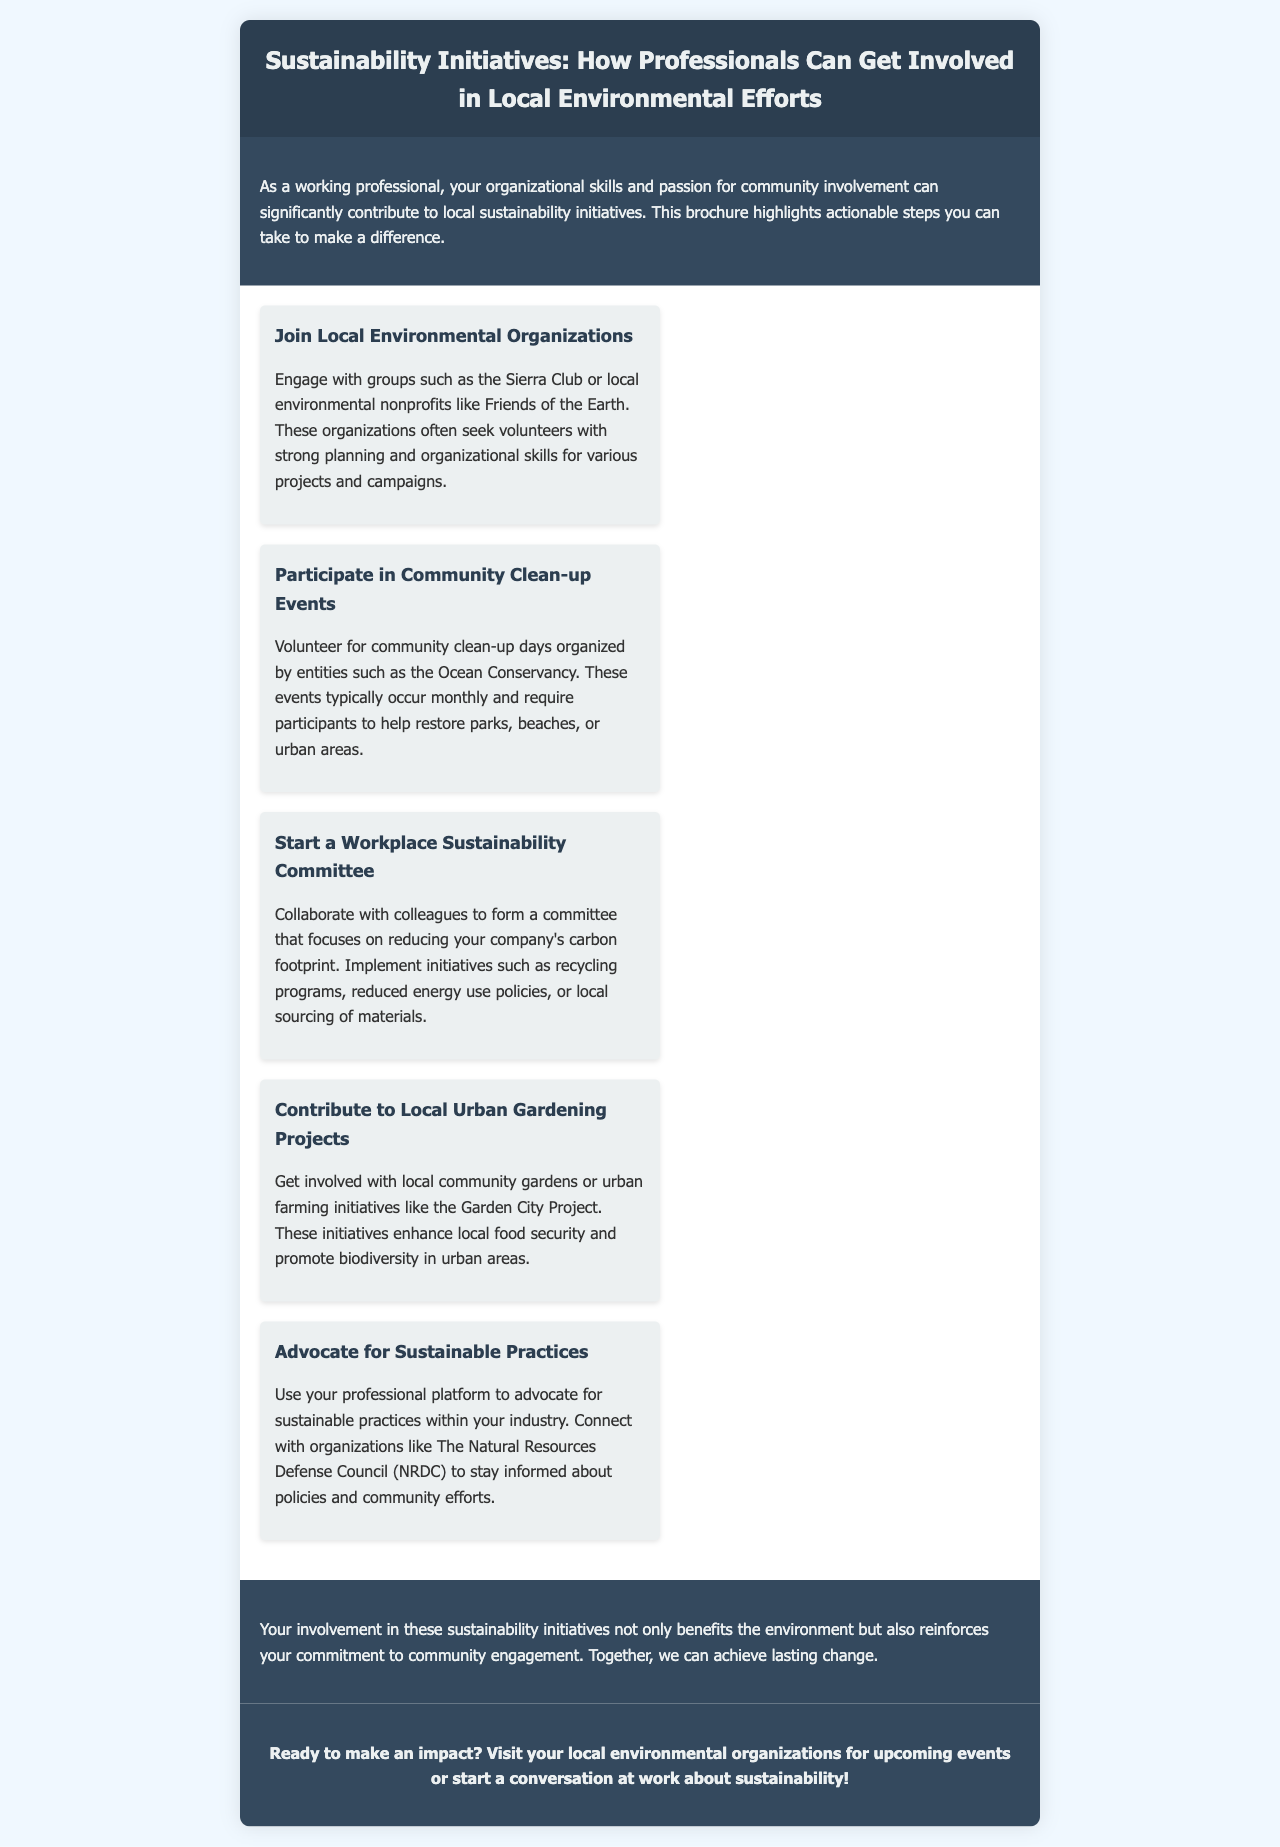What is the title of the brochure? The title is prominently displayed in the header of the document.
Answer: Sustainability Initiatives: How Professionals Can Get Involved in Local Environmental Efforts Who can contribute to local sustainability initiatives? The introductory paragraph mentions a specific group of people.
Answer: Working professionals Name two local environmental organizations mentioned in the brochure. The document lists these organizations as examples where professionals can engage.
Answer: Sierra Club, Friends of the Earth How often do community clean-up events typically occur? This is mentioned in the section about community clean-up events.
Answer: Monthly What project is suggested for enhancing local food security? The section discusses involvement in specific initiatives related to food.
Answer: Urban gardening projects What is the purpose of starting a workplace sustainability committee? The section explains the aim of forming a committee within a workplace.
Answer: Reducing carbon footprint What are volunteers asked to do at community clean-up days? This information is included in the section on community clean-up events.
Answer: Restore parks, beaches, or urban areas Which organization can professionals connect with to stay informed about sustainable policies? The advocacy section references this organization for awareness.
Answer: The Natural Resources Defense Council (NRDC) What is the main benefit of getting involved in sustainability initiatives? The conclusion outlines a key advantage of participation.
Answer: Benefit the environment 